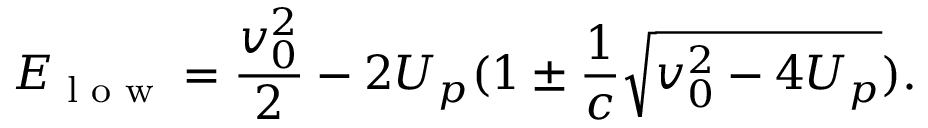Convert formula to latex. <formula><loc_0><loc_0><loc_500><loc_500>E _ { l o w } = \frac { v _ { 0 } ^ { 2 } } { 2 } - 2 U _ { p } ( 1 \pm \frac { 1 } { c } \sqrt { v _ { 0 } ^ { 2 } - 4 U _ { p } } ) .</formula> 